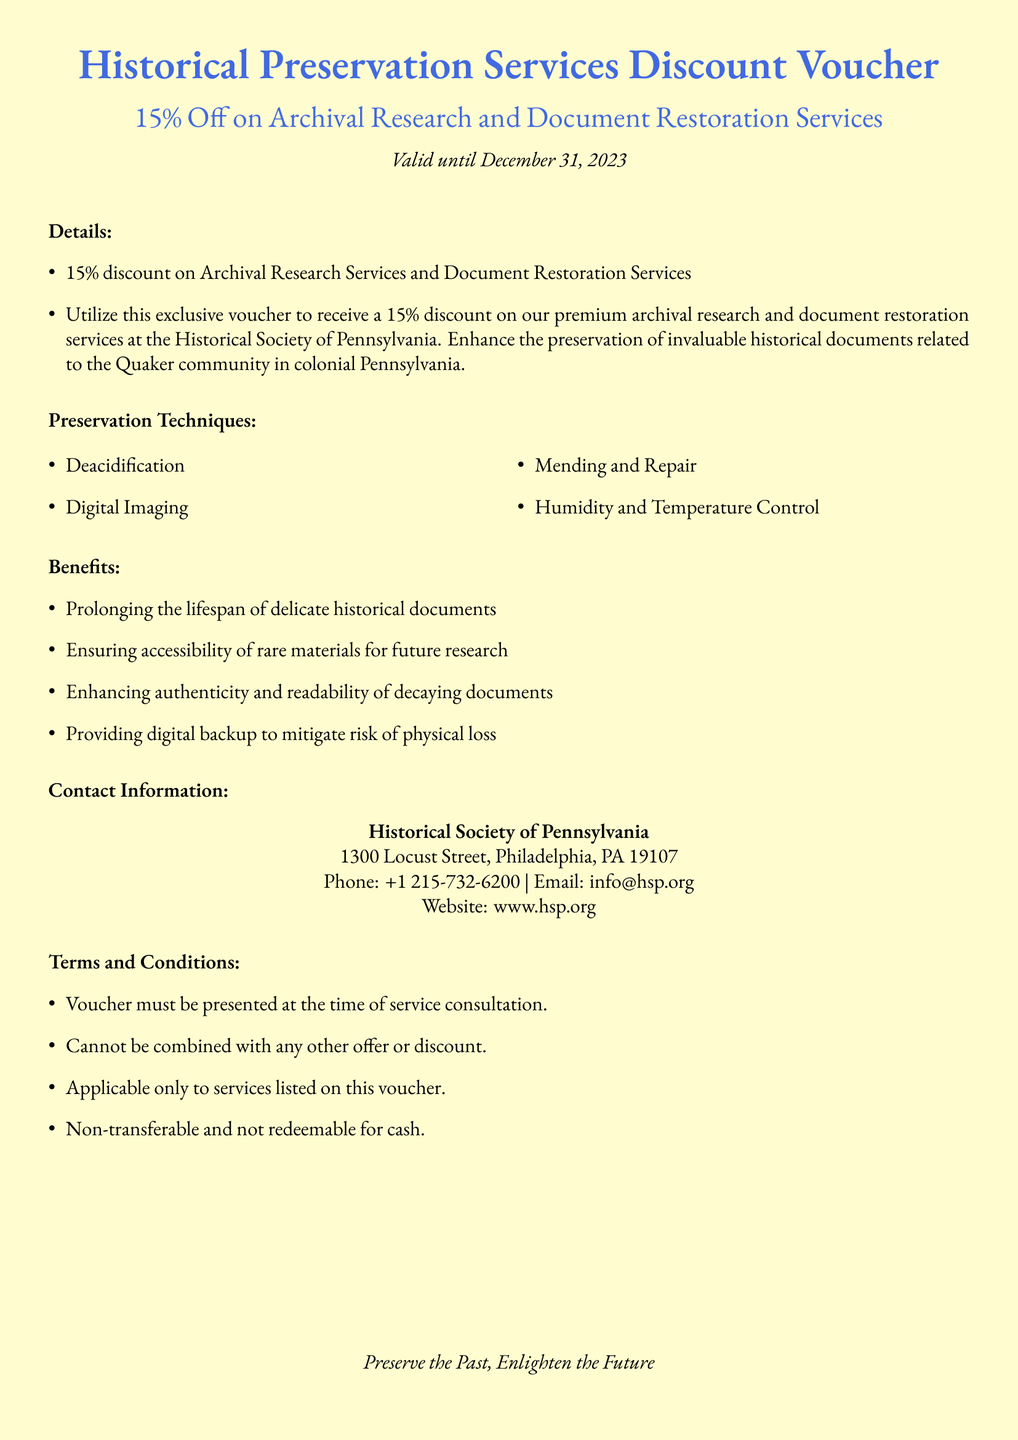What is the discount percentage? The discount percentage mentioned in the voucher is specified as 15%.
Answer: 15% What is the expiration date of the voucher? The validity period of the voucher is provided, which ends on December 31, 2023.
Answer: December 31, 2023 Where is the Historical Society of Pennsylvania located? The document provides an address for the Historical Society of Pennsylvania in Philadelphia, PA.
Answer: 1300 Locust Street, Philadelphia, PA 19107 What types of preservation techniques are mentioned? The document lists various preservation techniques, including deacidification and digital imaging.
Answer: Deacidification, Digital Imaging, Mending and Repair, Humidity and Temperature Control What benefit does digital backup provide? One of the benefits listed emphasizes mitigating the risk of physical loss through digital backup.
Answer: Mitigate risk of physical loss Can the voucher be combined with other offers? The terms and conditions specify whether the voucher can be combined with other promotions.
Answer: Cannot be combined What email address can be used for inquiries? The document lists a specific email address for contact purposes related to the voucher.
Answer: info@hsp.org Is the voucher transferable? The terms clearly outline the nature of the voucher regarding transferability.
Answer: Non-transferable 